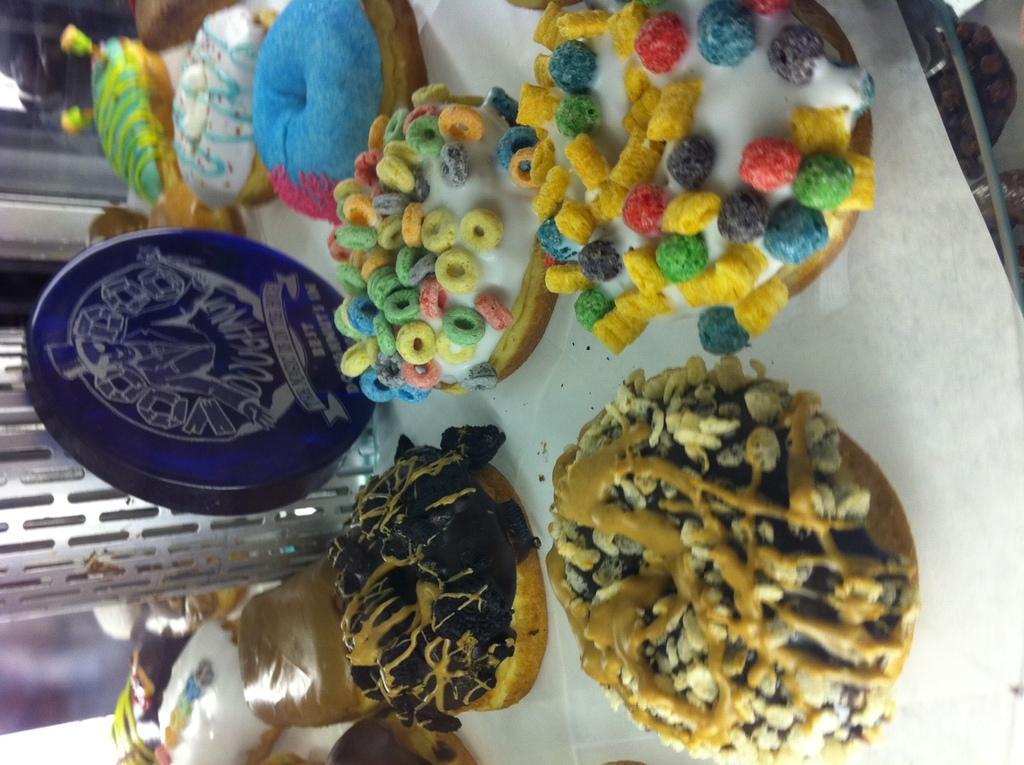Could you give a brief overview of what you see in this image? In this image I can see food items in different colors and blue color object. They are on the white color surface. 